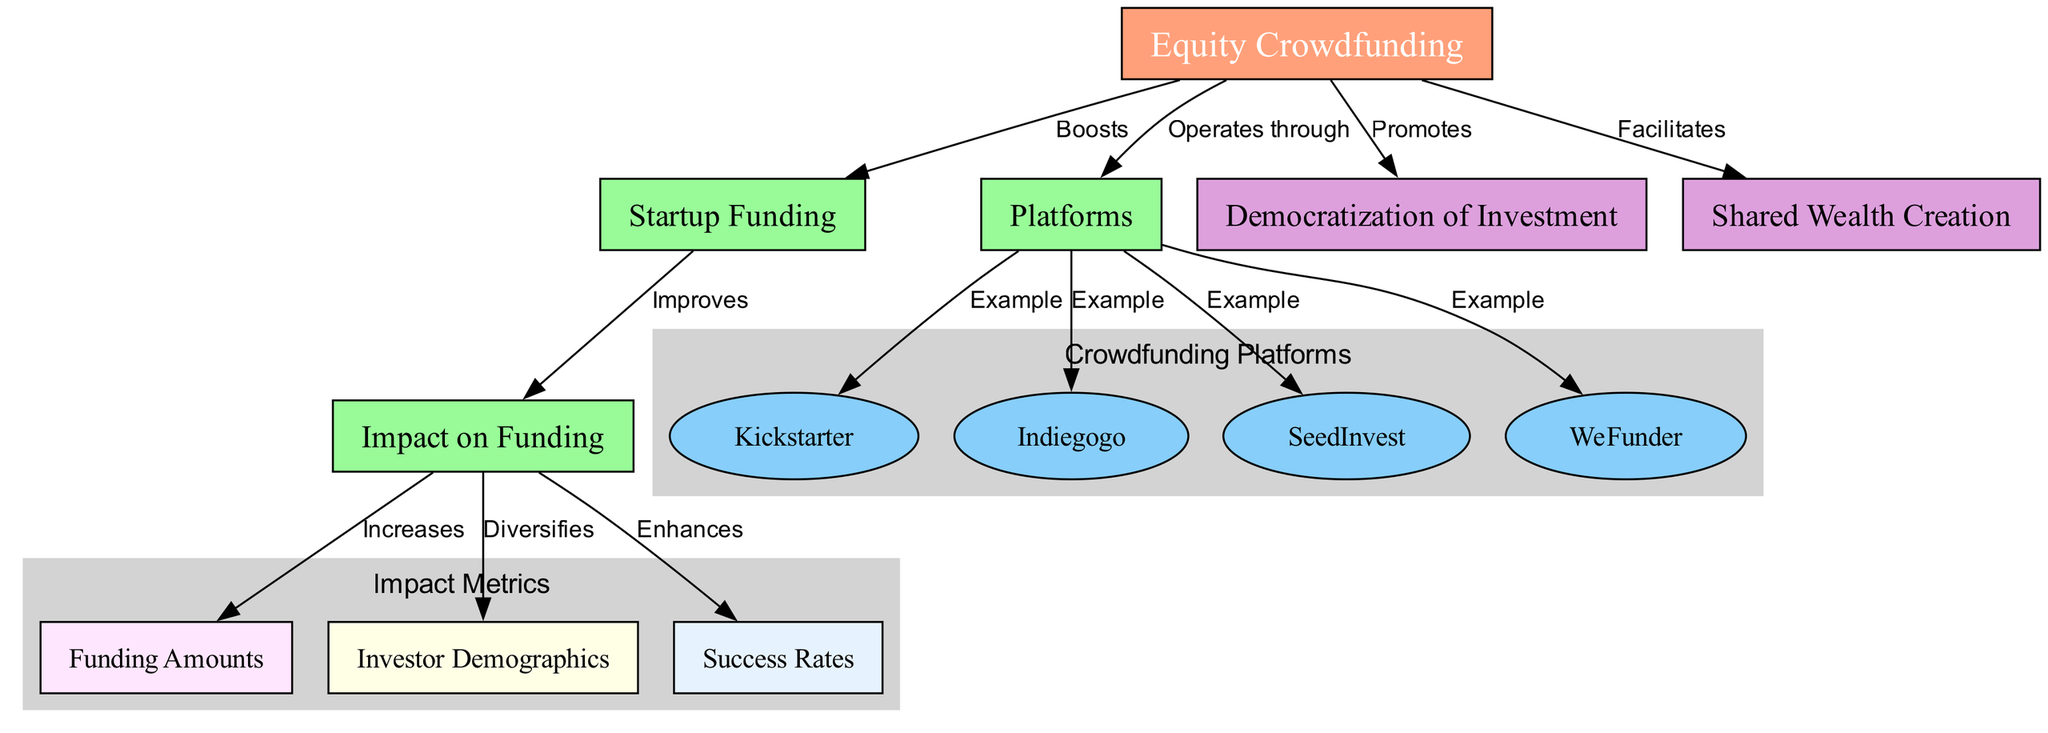What are the platforms mentioned in the diagram? The diagram lists four platforms as examples of equity crowdfunding: Kickstarter, Indiegogo, SeedInvest, and WeFunder.
Answer: Kickstarter, Indiegogo, SeedInvest, WeFunder How does equity crowdfunding impact startup funding? The diagram states that equity crowdfunding boosts startup funding, hence establishing a direct relationship between the two concepts.
Answer: Boosts What is the relationship between impact on funding and funding amounts? According to the diagram, the relationship is that the impact on funding increases funding amounts, indicating a positive effect.
Answer: Increases How many nodes are there in the diagram? The diagram consists of 12 nodes which represent various concepts related to equity crowdfunding and its effects.
Answer: 12 What is the main benefit of equity crowdfunding as shown in the diagram? The diagram highlights two main benefits of equity crowdfunding: it promotes the democratization of investment and facilitates shared wealth creation.
Answer: Promotes, Facilitates Which platform is highlighted as an example under the subgraph for crowdfunding platforms? The diagram designates Kickstarter as one of the examples under the crowdfunding platforms, indicating its prominent role in equity crowdfunding.
Answer: Kickstarter What impact does equity crowdfunding have on investor demographics? The diagram clearly states that equity crowdfunding diversifies investor demographics, thereby affecting the types of investors involved in startup funding.
Answer: Diversifies How does the relationship between startup funding and success rates work? The diagram indicates that the impact on funding enhances success rates; hence, an improvement in startup funding leads to higher success rates for startups.
Answer: Enhances What does the diagram suggest about the overall impact of equity crowdfunding? The overall impact as illustrated by the diagram suggests that equity crowdfunding promotes democratization of investment and enhances success rates, leading to shared wealth creation.
Answer: Democratization of Investment, Shared Wealth Creation 